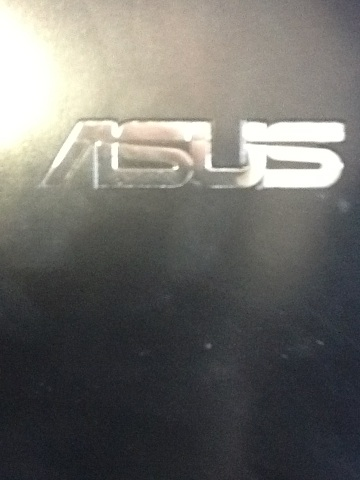Create a very creative question about this logo. If this Asus logo were to transform into a sentient digital assistant named 'AsusAI,' what unique features and personality traits would it have, and how would it interact with you during a day filled with various activities, from working on projects to unwinding with entertainment? 